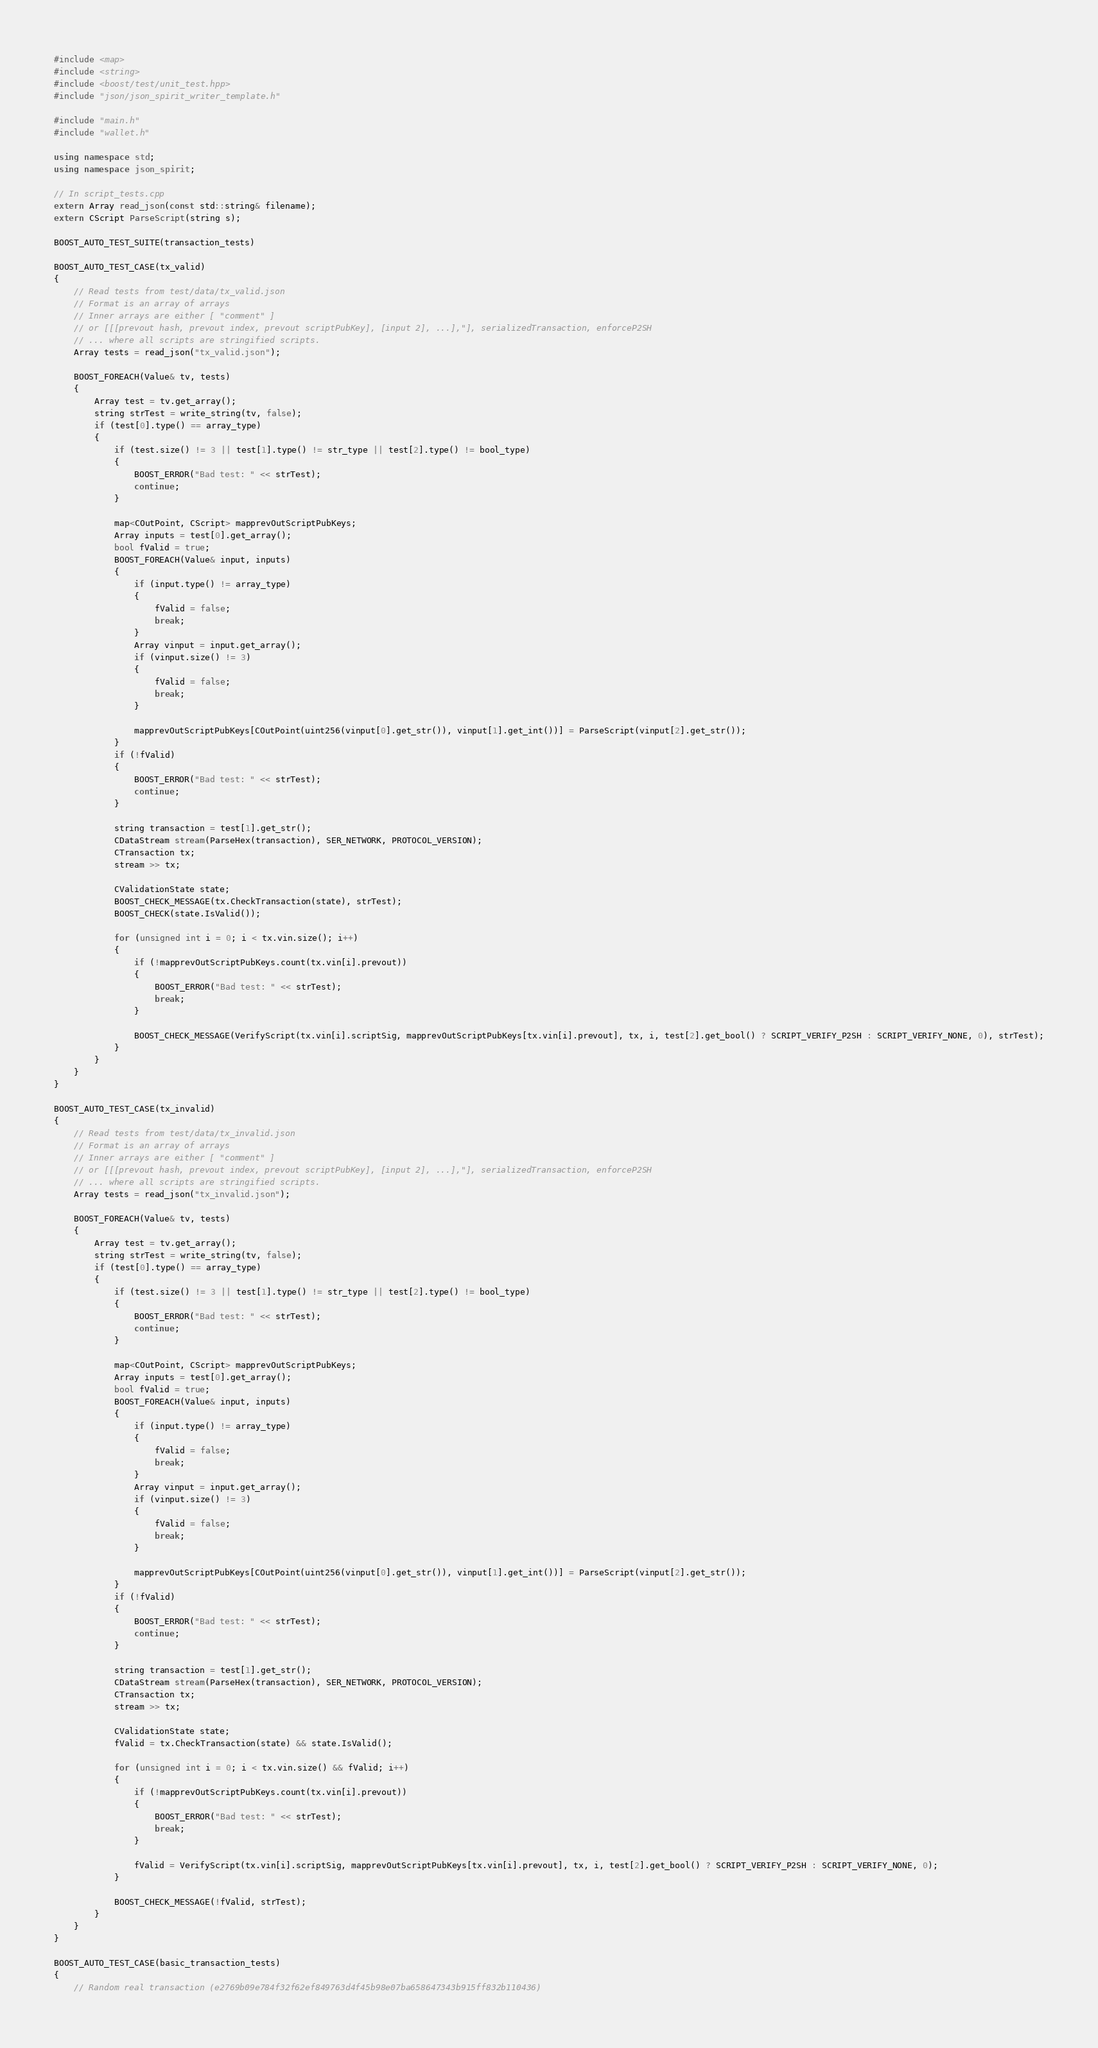Convert code to text. <code><loc_0><loc_0><loc_500><loc_500><_C++_>#include <map>
#include <string>
#include <boost/test/unit_test.hpp>
#include "json/json_spirit_writer_template.h"

#include "main.h"
#include "wallet.h"

using namespace std;
using namespace json_spirit;

// In script_tests.cpp
extern Array read_json(const std::string& filename);
extern CScript ParseScript(string s);

BOOST_AUTO_TEST_SUITE(transaction_tests)

BOOST_AUTO_TEST_CASE(tx_valid)
{
    // Read tests from test/data/tx_valid.json
    // Format is an array of arrays
    // Inner arrays are either [ "comment" ]
    // or [[[prevout hash, prevout index, prevout scriptPubKey], [input 2], ...],"], serializedTransaction, enforceP2SH
    // ... where all scripts are stringified scripts.
    Array tests = read_json("tx_valid.json");

    BOOST_FOREACH(Value& tv, tests)
    {
        Array test = tv.get_array();
        string strTest = write_string(tv, false);
        if (test[0].type() == array_type)
        {
            if (test.size() != 3 || test[1].type() != str_type || test[2].type() != bool_type)
            {
                BOOST_ERROR("Bad test: " << strTest);
                continue;
            }

            map<COutPoint, CScript> mapprevOutScriptPubKeys;
            Array inputs = test[0].get_array();
            bool fValid = true;
            BOOST_FOREACH(Value& input, inputs)
            {
                if (input.type() != array_type)
                {
                    fValid = false;
                    break;
                }
                Array vinput = input.get_array();
                if (vinput.size() != 3)
                {
                    fValid = false;
                    break;
                }

                mapprevOutScriptPubKeys[COutPoint(uint256(vinput[0].get_str()), vinput[1].get_int())] = ParseScript(vinput[2].get_str());
            }
            if (!fValid)
            {
                BOOST_ERROR("Bad test: " << strTest);
                continue;
            }

            string transaction = test[1].get_str();
            CDataStream stream(ParseHex(transaction), SER_NETWORK, PROTOCOL_VERSION);
            CTransaction tx;
            stream >> tx;

            CValidationState state;
            BOOST_CHECK_MESSAGE(tx.CheckTransaction(state), strTest);
            BOOST_CHECK(state.IsValid());

            for (unsigned int i = 0; i < tx.vin.size(); i++)
            {
                if (!mapprevOutScriptPubKeys.count(tx.vin[i].prevout))
                {
                    BOOST_ERROR("Bad test: " << strTest);
                    break;
                }

                BOOST_CHECK_MESSAGE(VerifyScript(tx.vin[i].scriptSig, mapprevOutScriptPubKeys[tx.vin[i].prevout], tx, i, test[2].get_bool() ? SCRIPT_VERIFY_P2SH : SCRIPT_VERIFY_NONE, 0), strTest);
            }
        }
    }
}

BOOST_AUTO_TEST_CASE(tx_invalid)
{
    // Read tests from test/data/tx_invalid.json
    // Format is an array of arrays
    // Inner arrays are either [ "comment" ]
    // or [[[prevout hash, prevout index, prevout scriptPubKey], [input 2], ...],"], serializedTransaction, enforceP2SH
    // ... where all scripts are stringified scripts.
    Array tests = read_json("tx_invalid.json");

    BOOST_FOREACH(Value& tv, tests)
    {
        Array test = tv.get_array();
        string strTest = write_string(tv, false);
        if (test[0].type() == array_type)
        {
            if (test.size() != 3 || test[1].type() != str_type || test[2].type() != bool_type)
            {
                BOOST_ERROR("Bad test: " << strTest);
                continue;
            }

            map<COutPoint, CScript> mapprevOutScriptPubKeys;
            Array inputs = test[0].get_array();
            bool fValid = true;
            BOOST_FOREACH(Value& input, inputs)
            {
                if (input.type() != array_type)
                {
                    fValid = false;
                    break;
                }
                Array vinput = input.get_array();
                if (vinput.size() != 3)
                {
                    fValid = false;
                    break;
                }

                mapprevOutScriptPubKeys[COutPoint(uint256(vinput[0].get_str()), vinput[1].get_int())] = ParseScript(vinput[2].get_str());
            }
            if (!fValid)
            {
                BOOST_ERROR("Bad test: " << strTest);
                continue;
            }

            string transaction = test[1].get_str();
            CDataStream stream(ParseHex(transaction), SER_NETWORK, PROTOCOL_VERSION);
            CTransaction tx;
            stream >> tx;

            CValidationState state;
            fValid = tx.CheckTransaction(state) && state.IsValid();

            for (unsigned int i = 0; i < tx.vin.size() && fValid; i++)
            {
                if (!mapprevOutScriptPubKeys.count(tx.vin[i].prevout))
                {
                    BOOST_ERROR("Bad test: " << strTest);
                    break;
                }

                fValid = VerifyScript(tx.vin[i].scriptSig, mapprevOutScriptPubKeys[tx.vin[i].prevout], tx, i, test[2].get_bool() ? SCRIPT_VERIFY_P2SH : SCRIPT_VERIFY_NONE, 0);
            }

            BOOST_CHECK_MESSAGE(!fValid, strTest);
        }
    }
}

BOOST_AUTO_TEST_CASE(basic_transaction_tests)
{
    // Random real transaction (e2769b09e784f32f62ef849763d4f45b98e07ba658647343b915ff832b110436)</code> 